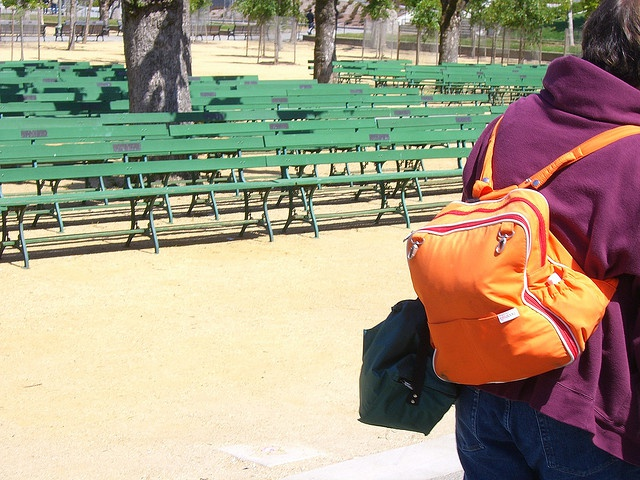Describe the objects in this image and their specific colors. I can see people in lightgray, black, purple, and orange tones, bench in lightgray, turquoise, beige, and black tones, backpack in lightgray, orange, brown, gold, and red tones, handbag in lightgray, black, darkblue, gray, and purple tones, and bench in lightgray, turquoise, black, teal, and gray tones in this image. 